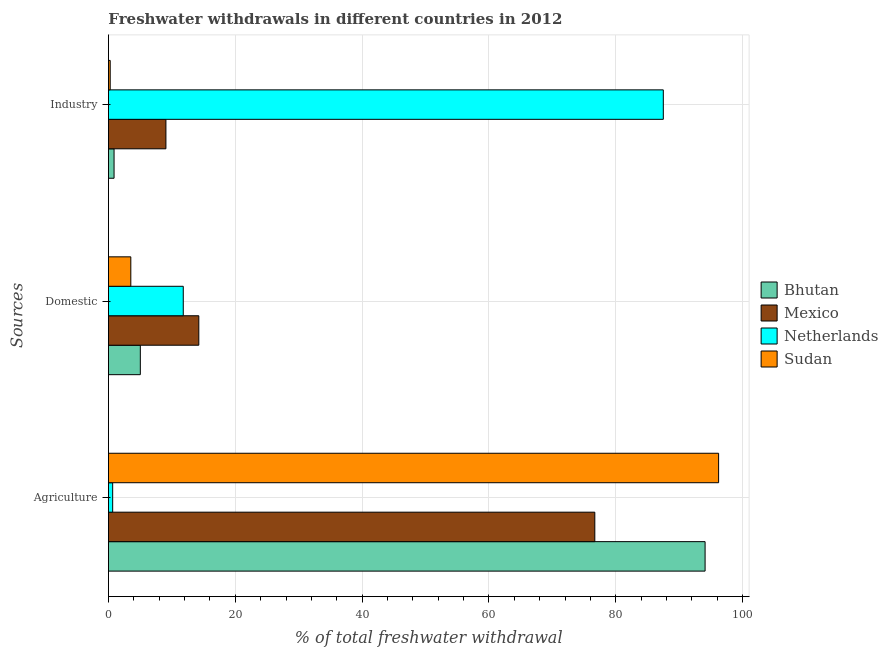How many different coloured bars are there?
Provide a short and direct response. 4. How many bars are there on the 1st tick from the top?
Your answer should be compact. 4. What is the label of the 3rd group of bars from the top?
Give a very brief answer. Agriculture. What is the percentage of freshwater withdrawal for agriculture in Bhutan?
Provide a succinct answer. 94.08. Across all countries, what is the maximum percentage of freshwater withdrawal for agriculture?
Ensure brevity in your answer.  96.21. Across all countries, what is the minimum percentage of freshwater withdrawal for domestic purposes?
Offer a terse response. 3.53. In which country was the percentage of freshwater withdrawal for industry maximum?
Ensure brevity in your answer.  Netherlands. In which country was the percentage of freshwater withdrawal for industry minimum?
Offer a very short reply. Sudan. What is the total percentage of freshwater withdrawal for industry in the graph?
Keep it short and to the point. 97.72. What is the difference between the percentage of freshwater withdrawal for domestic purposes in Bhutan and that in Netherlands?
Provide a short and direct response. -6.77. What is the difference between the percentage of freshwater withdrawal for industry in Sudan and the percentage of freshwater withdrawal for agriculture in Netherlands?
Your response must be concise. -0.39. What is the average percentage of freshwater withdrawal for agriculture per country?
Make the answer very short. 66.91. What is the difference between the percentage of freshwater withdrawal for domestic purposes and percentage of freshwater withdrawal for industry in Bhutan?
Provide a succinct answer. 4.14. What is the ratio of the percentage of freshwater withdrawal for industry in Mexico to that in Bhutan?
Provide a succinct answer. 10.21. What is the difference between the highest and the second highest percentage of freshwater withdrawal for agriculture?
Offer a terse response. 2.13. What is the difference between the highest and the lowest percentage of freshwater withdrawal for domestic purposes?
Your answer should be very brief. 10.72. In how many countries, is the percentage of freshwater withdrawal for agriculture greater than the average percentage of freshwater withdrawal for agriculture taken over all countries?
Keep it short and to the point. 3. Is the sum of the percentage of freshwater withdrawal for industry in Bhutan and Sudan greater than the maximum percentage of freshwater withdrawal for domestic purposes across all countries?
Provide a short and direct response. No. What does the 4th bar from the top in Agriculture represents?
Provide a short and direct response. Bhutan. What does the 1st bar from the bottom in Agriculture represents?
Your answer should be very brief. Bhutan. Is it the case that in every country, the sum of the percentage of freshwater withdrawal for agriculture and percentage of freshwater withdrawal for domestic purposes is greater than the percentage of freshwater withdrawal for industry?
Your answer should be very brief. No. How many bars are there?
Your answer should be very brief. 12. Are all the bars in the graph horizontal?
Make the answer very short. Yes. What is the difference between two consecutive major ticks on the X-axis?
Your answer should be very brief. 20. Where does the legend appear in the graph?
Offer a terse response. Center right. What is the title of the graph?
Give a very brief answer. Freshwater withdrawals in different countries in 2012. What is the label or title of the X-axis?
Your response must be concise. % of total freshwater withdrawal. What is the label or title of the Y-axis?
Your answer should be very brief. Sources. What is the % of total freshwater withdrawal in Bhutan in Agriculture?
Give a very brief answer. 94.08. What is the % of total freshwater withdrawal in Mexico in Agriculture?
Offer a very short reply. 76.69. What is the % of total freshwater withdrawal of Netherlands in Agriculture?
Make the answer very short. 0.67. What is the % of total freshwater withdrawal of Sudan in Agriculture?
Provide a succinct answer. 96.21. What is the % of total freshwater withdrawal of Bhutan in Domestic?
Keep it short and to the point. 5.03. What is the % of total freshwater withdrawal of Mexico in Domestic?
Ensure brevity in your answer.  14.25. What is the % of total freshwater withdrawal of Sudan in Domestic?
Offer a very short reply. 3.53. What is the % of total freshwater withdrawal of Bhutan in Industry?
Your response must be concise. 0.89. What is the % of total freshwater withdrawal in Mexico in Industry?
Your answer should be very brief. 9.07. What is the % of total freshwater withdrawal of Netherlands in Industry?
Give a very brief answer. 87.49. What is the % of total freshwater withdrawal of Sudan in Industry?
Offer a terse response. 0.28. Across all Sources, what is the maximum % of total freshwater withdrawal in Bhutan?
Offer a very short reply. 94.08. Across all Sources, what is the maximum % of total freshwater withdrawal in Mexico?
Give a very brief answer. 76.69. Across all Sources, what is the maximum % of total freshwater withdrawal of Netherlands?
Your answer should be very brief. 87.49. Across all Sources, what is the maximum % of total freshwater withdrawal in Sudan?
Your response must be concise. 96.21. Across all Sources, what is the minimum % of total freshwater withdrawal of Bhutan?
Give a very brief answer. 0.89. Across all Sources, what is the minimum % of total freshwater withdrawal in Mexico?
Offer a very short reply. 9.07. Across all Sources, what is the minimum % of total freshwater withdrawal in Netherlands?
Make the answer very short. 0.67. Across all Sources, what is the minimum % of total freshwater withdrawal of Sudan?
Provide a succinct answer. 0.28. What is the total % of total freshwater withdrawal of Bhutan in the graph?
Provide a succinct answer. 100. What is the total % of total freshwater withdrawal in Mexico in the graph?
Your answer should be compact. 100.01. What is the total % of total freshwater withdrawal of Netherlands in the graph?
Your answer should be very brief. 99.96. What is the total % of total freshwater withdrawal in Sudan in the graph?
Provide a succinct answer. 100.02. What is the difference between the % of total freshwater withdrawal of Bhutan in Agriculture and that in Domestic?
Offer a terse response. 89.05. What is the difference between the % of total freshwater withdrawal in Mexico in Agriculture and that in Domestic?
Provide a short and direct response. 62.44. What is the difference between the % of total freshwater withdrawal in Netherlands in Agriculture and that in Domestic?
Make the answer very short. -11.13. What is the difference between the % of total freshwater withdrawal of Sudan in Agriculture and that in Domestic?
Your response must be concise. 92.68. What is the difference between the % of total freshwater withdrawal in Bhutan in Agriculture and that in Industry?
Ensure brevity in your answer.  93.19. What is the difference between the % of total freshwater withdrawal of Mexico in Agriculture and that in Industry?
Your answer should be very brief. 67.62. What is the difference between the % of total freshwater withdrawal in Netherlands in Agriculture and that in Industry?
Provide a short and direct response. -86.82. What is the difference between the % of total freshwater withdrawal of Sudan in Agriculture and that in Industry?
Provide a succinct answer. 95.93. What is the difference between the % of total freshwater withdrawal in Bhutan in Domestic and that in Industry?
Ensure brevity in your answer.  4.14. What is the difference between the % of total freshwater withdrawal of Mexico in Domestic and that in Industry?
Your response must be concise. 5.18. What is the difference between the % of total freshwater withdrawal in Netherlands in Domestic and that in Industry?
Keep it short and to the point. -75.69. What is the difference between the % of total freshwater withdrawal in Sudan in Domestic and that in Industry?
Provide a succinct answer. 3.25. What is the difference between the % of total freshwater withdrawal of Bhutan in Agriculture and the % of total freshwater withdrawal of Mexico in Domestic?
Your response must be concise. 79.83. What is the difference between the % of total freshwater withdrawal in Bhutan in Agriculture and the % of total freshwater withdrawal in Netherlands in Domestic?
Your answer should be very brief. 82.28. What is the difference between the % of total freshwater withdrawal of Bhutan in Agriculture and the % of total freshwater withdrawal of Sudan in Domestic?
Your answer should be compact. 90.55. What is the difference between the % of total freshwater withdrawal of Mexico in Agriculture and the % of total freshwater withdrawal of Netherlands in Domestic?
Provide a succinct answer. 64.89. What is the difference between the % of total freshwater withdrawal of Mexico in Agriculture and the % of total freshwater withdrawal of Sudan in Domestic?
Keep it short and to the point. 73.16. What is the difference between the % of total freshwater withdrawal of Netherlands in Agriculture and the % of total freshwater withdrawal of Sudan in Domestic?
Offer a terse response. -2.86. What is the difference between the % of total freshwater withdrawal of Bhutan in Agriculture and the % of total freshwater withdrawal of Mexico in Industry?
Provide a short and direct response. 85.01. What is the difference between the % of total freshwater withdrawal in Bhutan in Agriculture and the % of total freshwater withdrawal in Netherlands in Industry?
Give a very brief answer. 6.59. What is the difference between the % of total freshwater withdrawal of Bhutan in Agriculture and the % of total freshwater withdrawal of Sudan in Industry?
Make the answer very short. 93.8. What is the difference between the % of total freshwater withdrawal in Mexico in Agriculture and the % of total freshwater withdrawal in Netherlands in Industry?
Make the answer very short. -10.8. What is the difference between the % of total freshwater withdrawal of Mexico in Agriculture and the % of total freshwater withdrawal of Sudan in Industry?
Your answer should be compact. 76.41. What is the difference between the % of total freshwater withdrawal of Netherlands in Agriculture and the % of total freshwater withdrawal of Sudan in Industry?
Make the answer very short. 0.39. What is the difference between the % of total freshwater withdrawal of Bhutan in Domestic and the % of total freshwater withdrawal of Mexico in Industry?
Offer a terse response. -4.04. What is the difference between the % of total freshwater withdrawal in Bhutan in Domestic and the % of total freshwater withdrawal in Netherlands in Industry?
Provide a succinct answer. -82.46. What is the difference between the % of total freshwater withdrawal in Bhutan in Domestic and the % of total freshwater withdrawal in Sudan in Industry?
Offer a terse response. 4.75. What is the difference between the % of total freshwater withdrawal in Mexico in Domestic and the % of total freshwater withdrawal in Netherlands in Industry?
Provide a succinct answer. -73.24. What is the difference between the % of total freshwater withdrawal of Mexico in Domestic and the % of total freshwater withdrawal of Sudan in Industry?
Provide a succinct answer. 13.97. What is the difference between the % of total freshwater withdrawal of Netherlands in Domestic and the % of total freshwater withdrawal of Sudan in Industry?
Your answer should be compact. 11.52. What is the average % of total freshwater withdrawal in Bhutan per Sources?
Make the answer very short. 33.33. What is the average % of total freshwater withdrawal of Mexico per Sources?
Your response must be concise. 33.34. What is the average % of total freshwater withdrawal in Netherlands per Sources?
Offer a very short reply. 33.32. What is the average % of total freshwater withdrawal in Sudan per Sources?
Provide a short and direct response. 33.34. What is the difference between the % of total freshwater withdrawal in Bhutan and % of total freshwater withdrawal in Mexico in Agriculture?
Your response must be concise. 17.39. What is the difference between the % of total freshwater withdrawal in Bhutan and % of total freshwater withdrawal in Netherlands in Agriculture?
Make the answer very short. 93.41. What is the difference between the % of total freshwater withdrawal of Bhutan and % of total freshwater withdrawal of Sudan in Agriculture?
Your response must be concise. -2.13. What is the difference between the % of total freshwater withdrawal in Mexico and % of total freshwater withdrawal in Netherlands in Agriculture?
Provide a short and direct response. 76.02. What is the difference between the % of total freshwater withdrawal of Mexico and % of total freshwater withdrawal of Sudan in Agriculture?
Make the answer very short. -19.52. What is the difference between the % of total freshwater withdrawal in Netherlands and % of total freshwater withdrawal in Sudan in Agriculture?
Ensure brevity in your answer.  -95.54. What is the difference between the % of total freshwater withdrawal in Bhutan and % of total freshwater withdrawal in Mexico in Domestic?
Give a very brief answer. -9.22. What is the difference between the % of total freshwater withdrawal of Bhutan and % of total freshwater withdrawal of Netherlands in Domestic?
Provide a succinct answer. -6.77. What is the difference between the % of total freshwater withdrawal of Bhutan and % of total freshwater withdrawal of Sudan in Domestic?
Your response must be concise. 1.5. What is the difference between the % of total freshwater withdrawal in Mexico and % of total freshwater withdrawal in Netherlands in Domestic?
Provide a succinct answer. 2.45. What is the difference between the % of total freshwater withdrawal of Mexico and % of total freshwater withdrawal of Sudan in Domestic?
Keep it short and to the point. 10.72. What is the difference between the % of total freshwater withdrawal of Netherlands and % of total freshwater withdrawal of Sudan in Domestic?
Make the answer very short. 8.27. What is the difference between the % of total freshwater withdrawal in Bhutan and % of total freshwater withdrawal in Mexico in Industry?
Keep it short and to the point. -8.18. What is the difference between the % of total freshwater withdrawal of Bhutan and % of total freshwater withdrawal of Netherlands in Industry?
Your answer should be very brief. -86.6. What is the difference between the % of total freshwater withdrawal of Bhutan and % of total freshwater withdrawal of Sudan in Industry?
Make the answer very short. 0.61. What is the difference between the % of total freshwater withdrawal of Mexico and % of total freshwater withdrawal of Netherlands in Industry?
Provide a short and direct response. -78.42. What is the difference between the % of total freshwater withdrawal in Mexico and % of total freshwater withdrawal in Sudan in Industry?
Offer a terse response. 8.79. What is the difference between the % of total freshwater withdrawal of Netherlands and % of total freshwater withdrawal of Sudan in Industry?
Give a very brief answer. 87.21. What is the ratio of the % of total freshwater withdrawal in Bhutan in Agriculture to that in Domestic?
Offer a very short reply. 18.7. What is the ratio of the % of total freshwater withdrawal of Mexico in Agriculture to that in Domestic?
Keep it short and to the point. 5.38. What is the ratio of the % of total freshwater withdrawal in Netherlands in Agriculture to that in Domestic?
Make the answer very short. 0.06. What is the ratio of the % of total freshwater withdrawal in Sudan in Agriculture to that in Domestic?
Make the answer very short. 27.27. What is the ratio of the % of total freshwater withdrawal of Bhutan in Agriculture to that in Industry?
Your response must be concise. 105.99. What is the ratio of the % of total freshwater withdrawal in Mexico in Agriculture to that in Industry?
Offer a very short reply. 8.46. What is the ratio of the % of total freshwater withdrawal of Netherlands in Agriculture to that in Industry?
Provide a short and direct response. 0.01. What is the ratio of the % of total freshwater withdrawal in Sudan in Agriculture to that in Industry?
Provide a succinct answer. 345.46. What is the ratio of the % of total freshwater withdrawal in Bhutan in Domestic to that in Industry?
Offer a terse response. 5.67. What is the ratio of the % of total freshwater withdrawal of Mexico in Domestic to that in Industry?
Your response must be concise. 1.57. What is the ratio of the % of total freshwater withdrawal of Netherlands in Domestic to that in Industry?
Your answer should be compact. 0.13. What is the ratio of the % of total freshwater withdrawal of Sudan in Domestic to that in Industry?
Offer a terse response. 12.67. What is the difference between the highest and the second highest % of total freshwater withdrawal in Bhutan?
Make the answer very short. 89.05. What is the difference between the highest and the second highest % of total freshwater withdrawal of Mexico?
Provide a succinct answer. 62.44. What is the difference between the highest and the second highest % of total freshwater withdrawal in Netherlands?
Give a very brief answer. 75.69. What is the difference between the highest and the second highest % of total freshwater withdrawal in Sudan?
Offer a very short reply. 92.68. What is the difference between the highest and the lowest % of total freshwater withdrawal in Bhutan?
Provide a succinct answer. 93.19. What is the difference between the highest and the lowest % of total freshwater withdrawal in Mexico?
Give a very brief answer. 67.62. What is the difference between the highest and the lowest % of total freshwater withdrawal of Netherlands?
Provide a succinct answer. 86.82. What is the difference between the highest and the lowest % of total freshwater withdrawal of Sudan?
Your answer should be very brief. 95.93. 